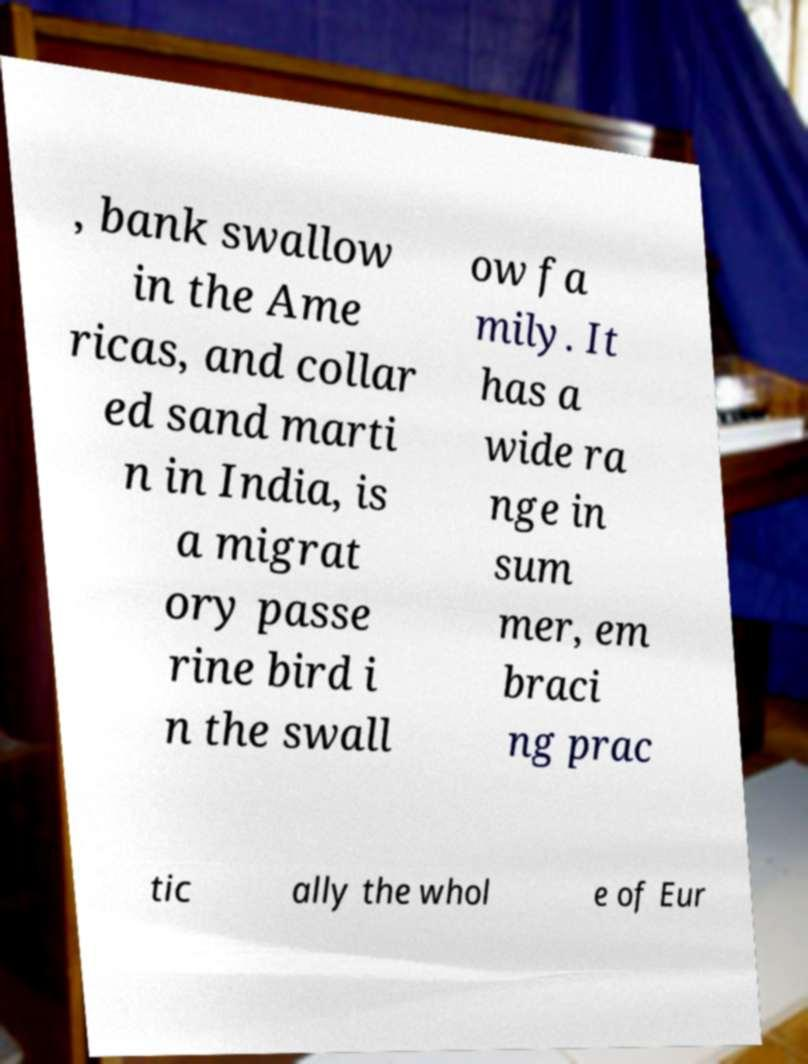Can you accurately transcribe the text from the provided image for me? , bank swallow in the Ame ricas, and collar ed sand marti n in India, is a migrat ory passe rine bird i n the swall ow fa mily. It has a wide ra nge in sum mer, em braci ng prac tic ally the whol e of Eur 